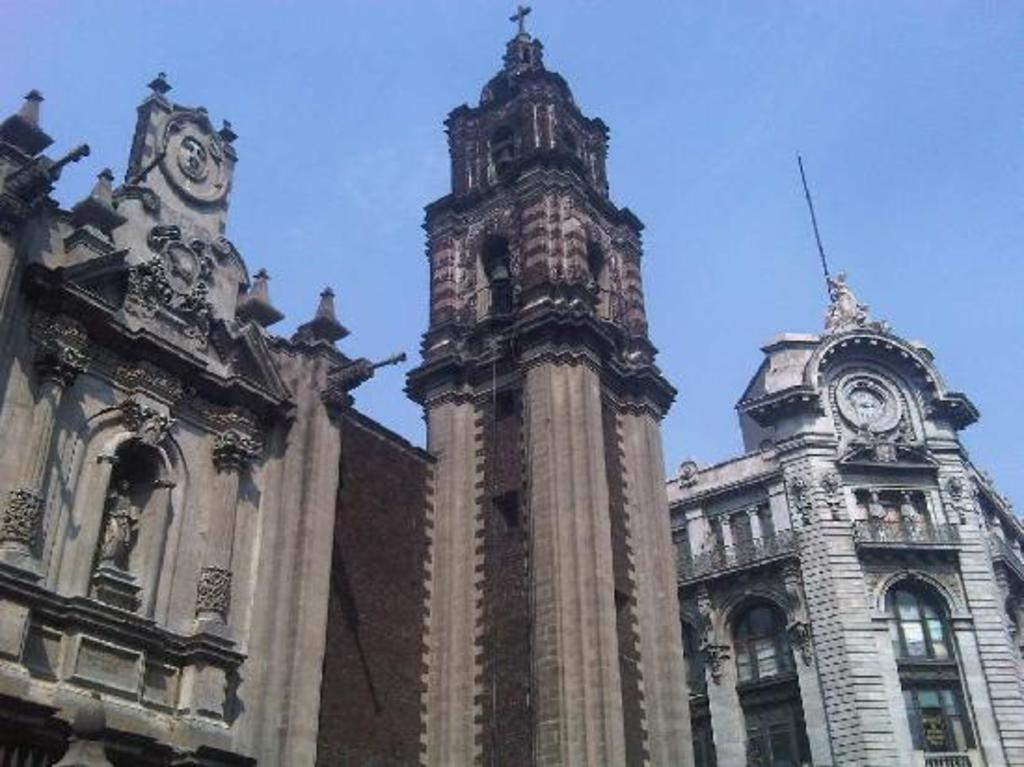What type of structures can be seen in the image? There are buildings in the image. Are there any other objects or features in the image besides the buildings? Yes, there are statues and a pole in the image. What can be seen on the buildings in the image? There are windows on the buildings in the image. What is visible in the background of the image? The sky is visible in the background of the image. How much money can be seen on the statues in the image? There is no money present on the statues in the image. What type of material can be rubbed off the pole in the image? There is no indication of any material that can be rubbed off the pole in the image. 